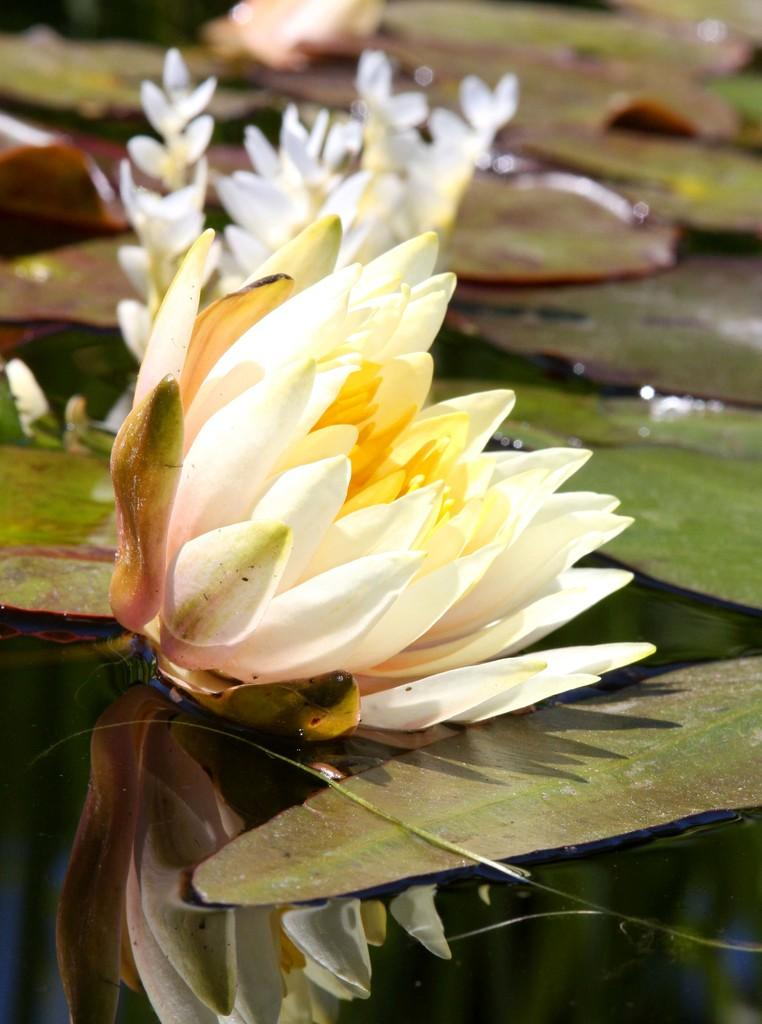What is the primary element in the image? There is water in the image. What types of plants can be seen in the water? There are white-colored flowers in the water. What color are the leaves in the image? There are green-colored leaves in the image. How would you describe the overall clarity of the image? The image is slightly blurry in the background. Can you tell me how many nerves are visible in the image? There are no nerves present in the image; it features water with white-colored flowers and green-colored leaves. What type of trail can be seen in the image? There is no trail present in the image; it features water with white-colored flowers and green-colored leaves. 